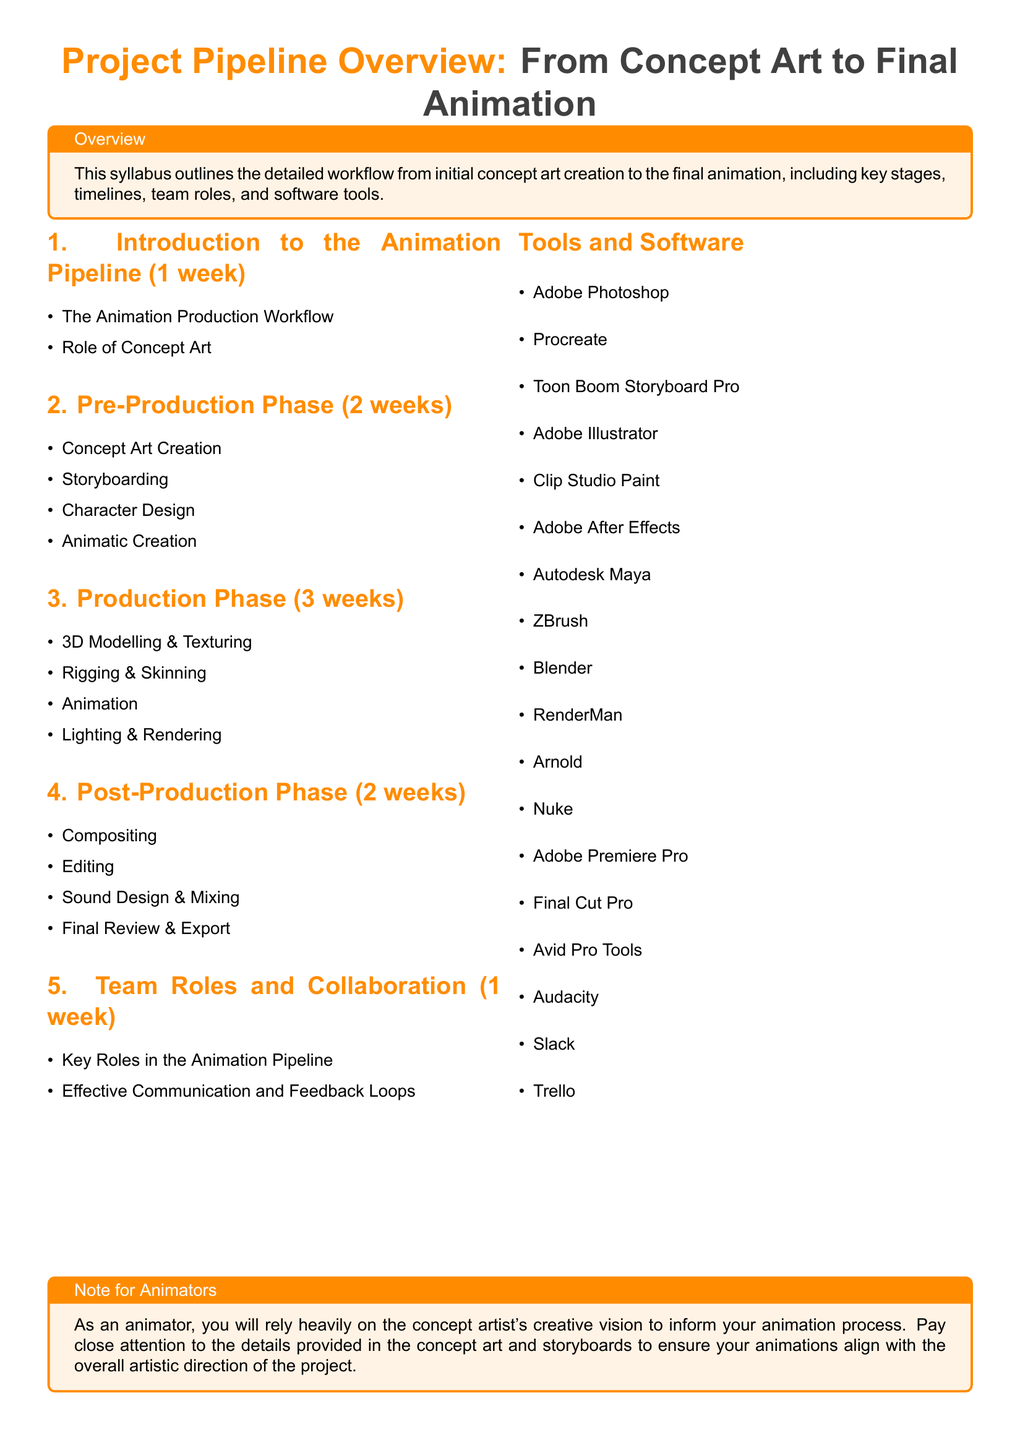What is the total duration of the pre-production phase? The pre-production phase lasts for 2 weeks as stated in the syllabus.
Answer: 2 weeks How many weeks is allocated to the production phase? The production phase is specifically stated to take 3 weeks in the document.
Answer: 3 weeks Which software is used for sound design and mixing? The software mentioned for sound design and mixing is Avid Pro Tools according to the document.
Answer: Avid Pro Tools What is the main role of concept art in the animation process? The document specifies that the role of concept art is crucial in informing the animation process.
Answer: Informing animation Name a tool mentioned for storyboard creation. The syllabus lists Toon Boom Storyboard Pro as a tool for storyboard creation.
Answer: Toon Boom Storyboard Pro How long is the post-production phase? The length of the post-production phase is indicated as 2 weeks in the syllabus.
Answer: 2 weeks What is one key aspect of team collaboration mentioned? Effective communication is highlighted as a key aspect in team roles and collaboration.
Answer: Effective communication What is the primary focus of the introduction section? The introduction section focuses on the animation production workflow and the role of concept art.
Answer: Animation production workflow What is the final step in the animation pipeline? The final review and export stage is the last step in the animation pipeline according to the document.
Answer: Final Review & Export 